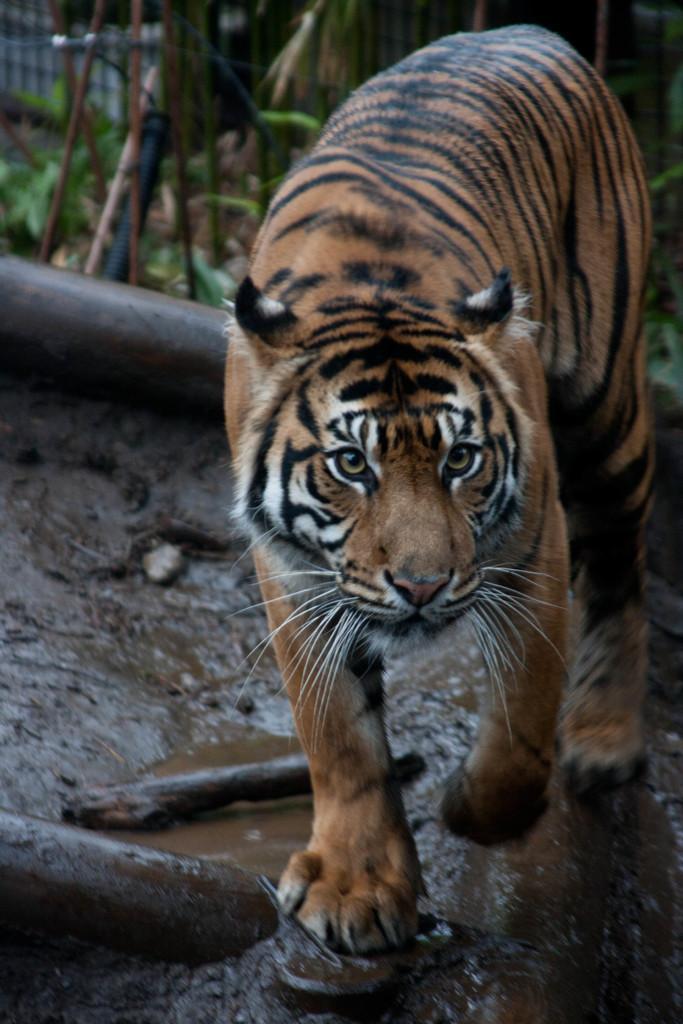Can you describe this image briefly? In the center of the image we can see a tiger, one black color object, rods, water and mud. In the background, we can see it is blurred. 